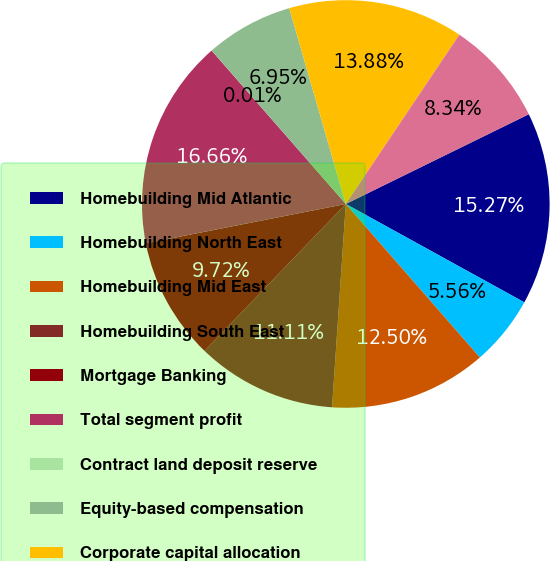Convert chart to OTSL. <chart><loc_0><loc_0><loc_500><loc_500><pie_chart><fcel>Homebuilding Mid Atlantic<fcel>Homebuilding North East<fcel>Homebuilding Mid East<fcel>Homebuilding South East<fcel>Mortgage Banking<fcel>Total segment profit<fcel>Contract land deposit reserve<fcel>Equity-based compensation<fcel>Corporate capital allocation<fcel>Unallocated corporate overhead<nl><fcel>15.27%<fcel>5.56%<fcel>12.5%<fcel>11.11%<fcel>9.72%<fcel>16.66%<fcel>0.01%<fcel>6.95%<fcel>13.88%<fcel>8.34%<nl></chart> 